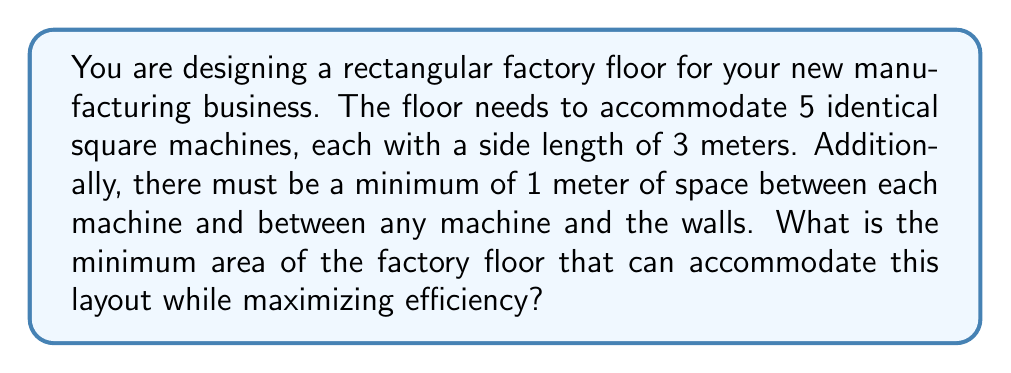Show me your answer to this math problem. To solve this problem, we need to find the most efficient arrangement of the machines that minimizes the total area. Let's approach this step-by-step:

1) First, we need to consider the effective size of each machine, including the required spacing:
   Each machine is 3m x 3m, with 1m spacing on each side.
   Effective size = $3m + 1m + 1m = 5m$ on each side

2) Now, we need to find the most efficient arrangement of 5 such squares.
   The most compact arrangement for 5 squares is typically a 3-2 configuration:
   3 squares in one row, 2 squares in another.

3) Let's calculate the dimensions of this arrangement:
   Width: $5m * 3 = 15m$ (3 machines side by side)
   Height: $5m * 2 = 10m$ (2 machines stacked vertically)

4) However, we need to add 1m to each dimension for the spacing between the outer machines and the walls:
   Total Width: $15m + 1m = 16m$
   Total Height: $10m + 1m = 11m$

5) The total area is then calculated as:
   $$A = 16m * 11m = 176m^2$$

This arrangement ensures that all spacing requirements are met while minimizing the total area.
Answer: The minimum area of the factory floor that can accommodate the 5 machines efficiently is $176m^2$. 